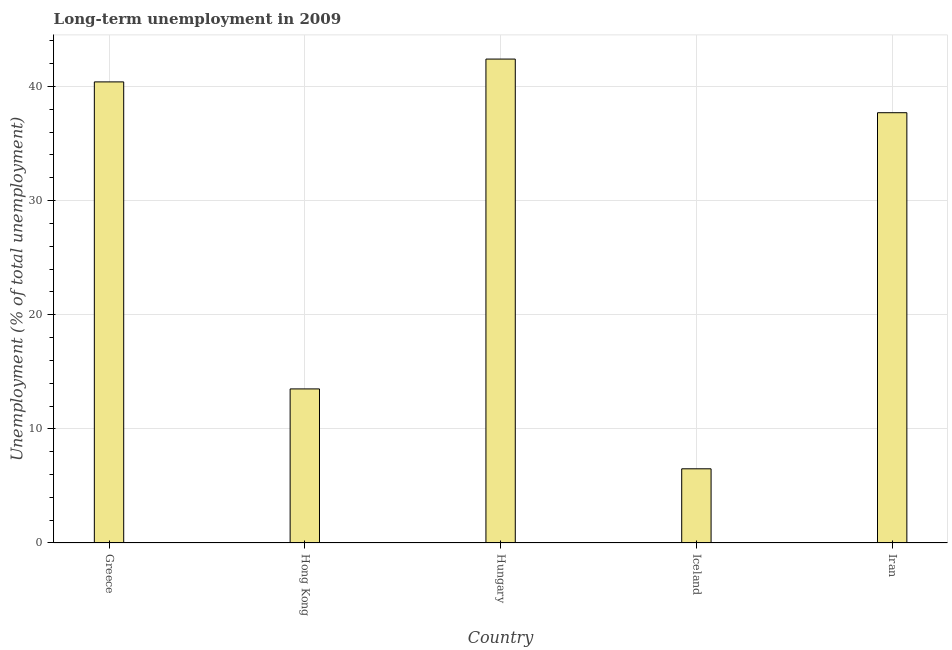What is the title of the graph?
Your answer should be compact. Long-term unemployment in 2009. What is the label or title of the X-axis?
Offer a terse response. Country. What is the label or title of the Y-axis?
Ensure brevity in your answer.  Unemployment (% of total unemployment). What is the long-term unemployment in Iceland?
Give a very brief answer. 6.5. Across all countries, what is the maximum long-term unemployment?
Make the answer very short. 42.4. In which country was the long-term unemployment maximum?
Provide a short and direct response. Hungary. In which country was the long-term unemployment minimum?
Offer a very short reply. Iceland. What is the sum of the long-term unemployment?
Offer a terse response. 140.5. What is the difference between the long-term unemployment in Hong Kong and Hungary?
Ensure brevity in your answer.  -28.9. What is the average long-term unemployment per country?
Provide a succinct answer. 28.1. What is the median long-term unemployment?
Give a very brief answer. 37.7. What is the ratio of the long-term unemployment in Greece to that in Hungary?
Offer a very short reply. 0.95. Is the difference between the long-term unemployment in Greece and Hong Kong greater than the difference between any two countries?
Provide a succinct answer. No. What is the difference between the highest and the second highest long-term unemployment?
Give a very brief answer. 2. Is the sum of the long-term unemployment in Greece and Iran greater than the maximum long-term unemployment across all countries?
Provide a short and direct response. Yes. What is the difference between the highest and the lowest long-term unemployment?
Provide a short and direct response. 35.9. How many bars are there?
Make the answer very short. 5. How many countries are there in the graph?
Provide a succinct answer. 5. Are the values on the major ticks of Y-axis written in scientific E-notation?
Ensure brevity in your answer.  No. What is the Unemployment (% of total unemployment) of Greece?
Your answer should be compact. 40.4. What is the Unemployment (% of total unemployment) in Hungary?
Give a very brief answer. 42.4. What is the Unemployment (% of total unemployment) in Iran?
Provide a succinct answer. 37.7. What is the difference between the Unemployment (% of total unemployment) in Greece and Hong Kong?
Your answer should be compact. 26.9. What is the difference between the Unemployment (% of total unemployment) in Greece and Hungary?
Provide a short and direct response. -2. What is the difference between the Unemployment (% of total unemployment) in Greece and Iceland?
Give a very brief answer. 33.9. What is the difference between the Unemployment (% of total unemployment) in Hong Kong and Hungary?
Keep it short and to the point. -28.9. What is the difference between the Unemployment (% of total unemployment) in Hong Kong and Iceland?
Your answer should be compact. 7. What is the difference between the Unemployment (% of total unemployment) in Hong Kong and Iran?
Provide a succinct answer. -24.2. What is the difference between the Unemployment (% of total unemployment) in Hungary and Iceland?
Provide a succinct answer. 35.9. What is the difference between the Unemployment (% of total unemployment) in Hungary and Iran?
Offer a very short reply. 4.7. What is the difference between the Unemployment (% of total unemployment) in Iceland and Iran?
Give a very brief answer. -31.2. What is the ratio of the Unemployment (% of total unemployment) in Greece to that in Hong Kong?
Keep it short and to the point. 2.99. What is the ratio of the Unemployment (% of total unemployment) in Greece to that in Hungary?
Offer a terse response. 0.95. What is the ratio of the Unemployment (% of total unemployment) in Greece to that in Iceland?
Offer a terse response. 6.21. What is the ratio of the Unemployment (% of total unemployment) in Greece to that in Iran?
Offer a very short reply. 1.07. What is the ratio of the Unemployment (% of total unemployment) in Hong Kong to that in Hungary?
Make the answer very short. 0.32. What is the ratio of the Unemployment (% of total unemployment) in Hong Kong to that in Iceland?
Offer a very short reply. 2.08. What is the ratio of the Unemployment (% of total unemployment) in Hong Kong to that in Iran?
Provide a succinct answer. 0.36. What is the ratio of the Unemployment (% of total unemployment) in Hungary to that in Iceland?
Your answer should be very brief. 6.52. What is the ratio of the Unemployment (% of total unemployment) in Iceland to that in Iran?
Offer a terse response. 0.17. 